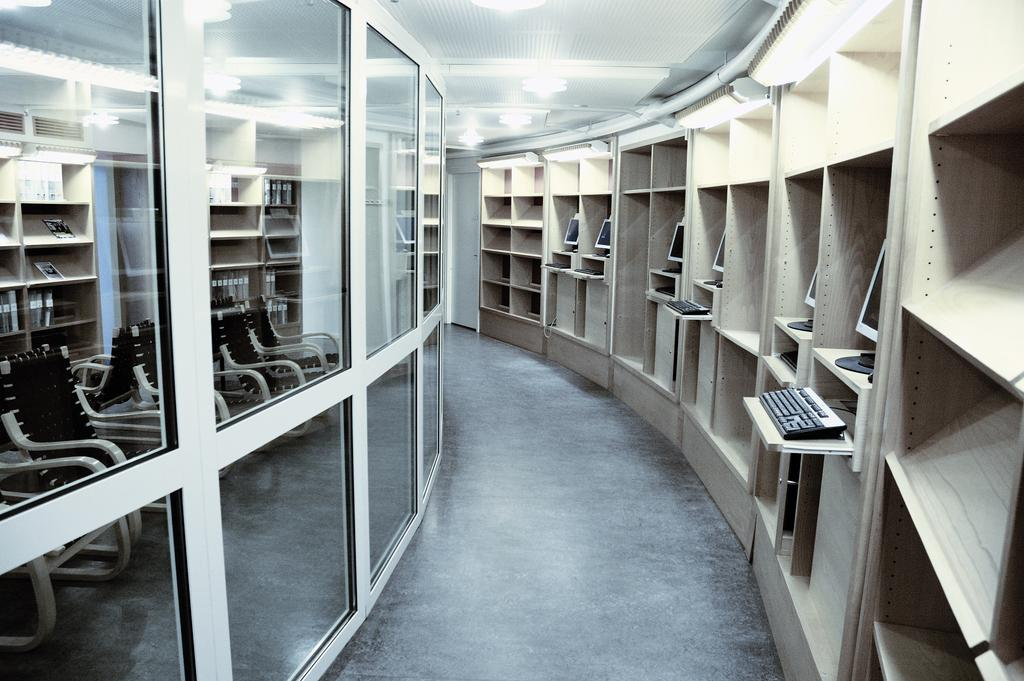What is the primary surface visible in the image? There is a floor in the image. What type of electronic devices can be seen in the image? Monitors and keyboards are visible in the image. What type of furniture is present in the image? Chairs are in the image. What type of structure is present in the image? Racks are present in the image. What type of material is present in the image? There is glass in the image. What type of illumination is present in the image? There are lights in the background of the image. What part of the room is visible in the background of the image? The ceiling is visible in the background of the image. How many horses are present in the image? There are no horses present in the image. What type of rhythm is being played by the expert in the image? There is no expert or rhythm present in the image. 